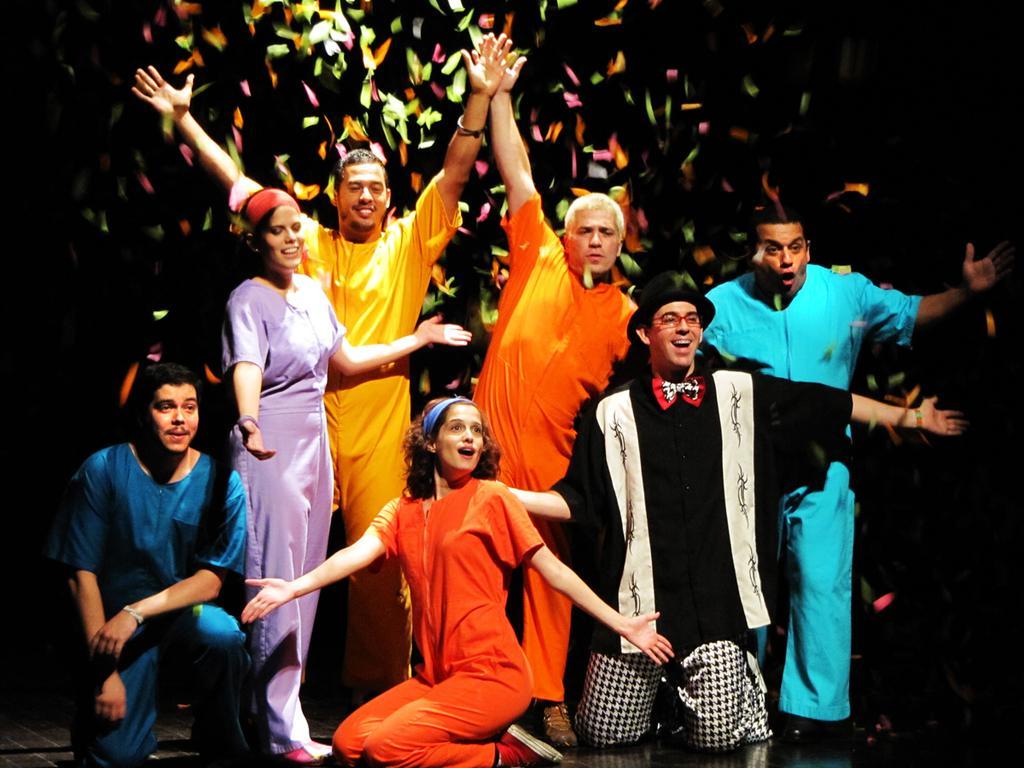How would you summarize this image in a sentence or two? This picture shows few people standing and few are seated on the knees and we see a man wore a cap on his head and we see color papers. 